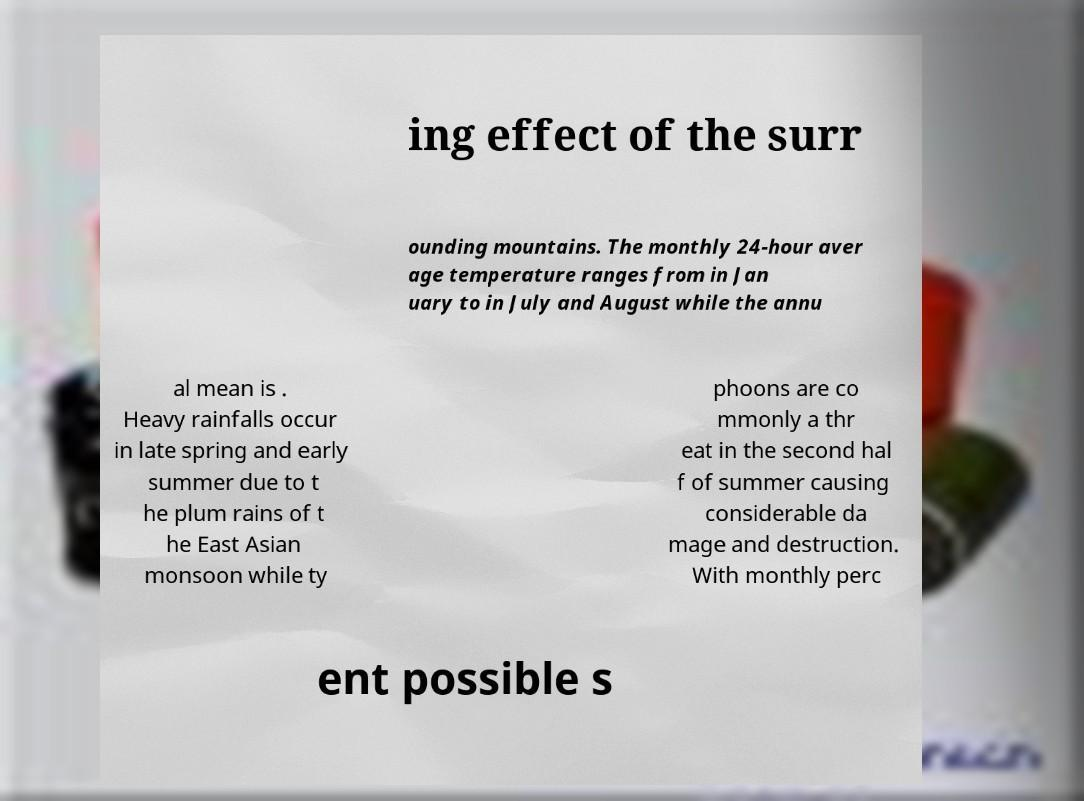Could you assist in decoding the text presented in this image and type it out clearly? ing effect of the surr ounding mountains. The monthly 24-hour aver age temperature ranges from in Jan uary to in July and August while the annu al mean is . Heavy rainfalls occur in late spring and early summer due to t he plum rains of t he East Asian monsoon while ty phoons are co mmonly a thr eat in the second hal f of summer causing considerable da mage and destruction. With monthly perc ent possible s 